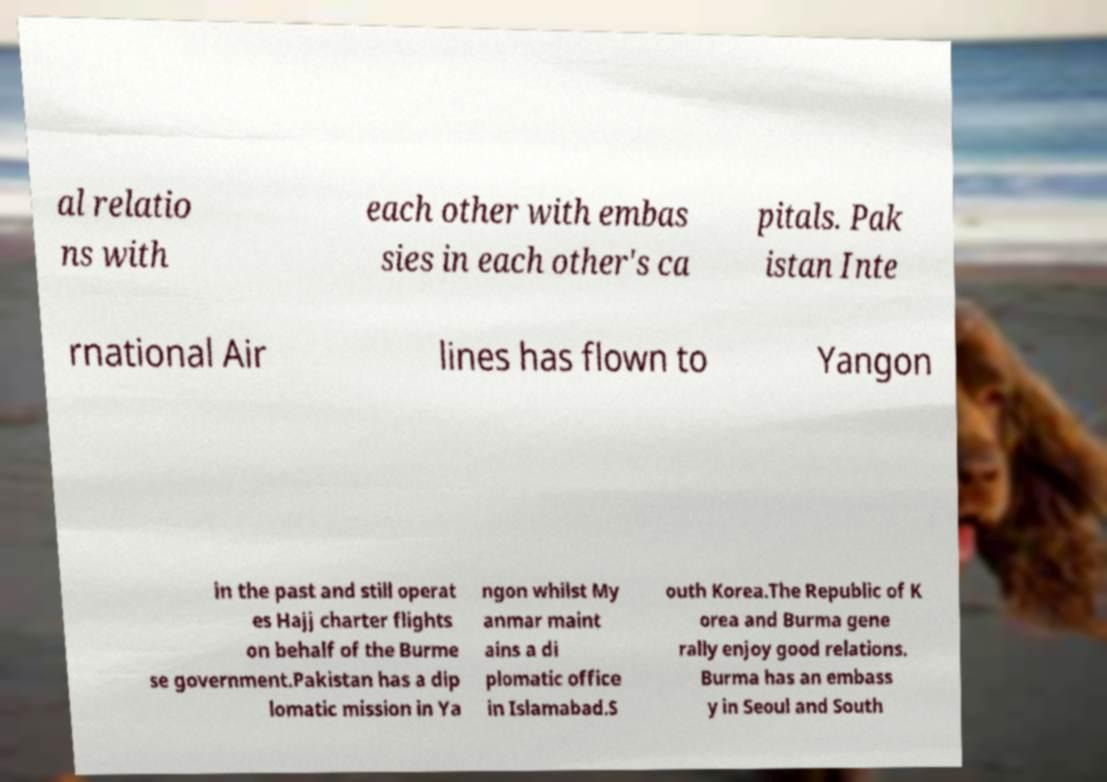Please identify and transcribe the text found in this image. al relatio ns with each other with embas sies in each other's ca pitals. Pak istan Inte rnational Air lines has flown to Yangon in the past and still operat es Hajj charter flights on behalf of the Burme se government.Pakistan has a dip lomatic mission in Ya ngon whilst My anmar maint ains a di plomatic office in Islamabad.S outh Korea.The Republic of K orea and Burma gene rally enjoy good relations. Burma has an embass y in Seoul and South 